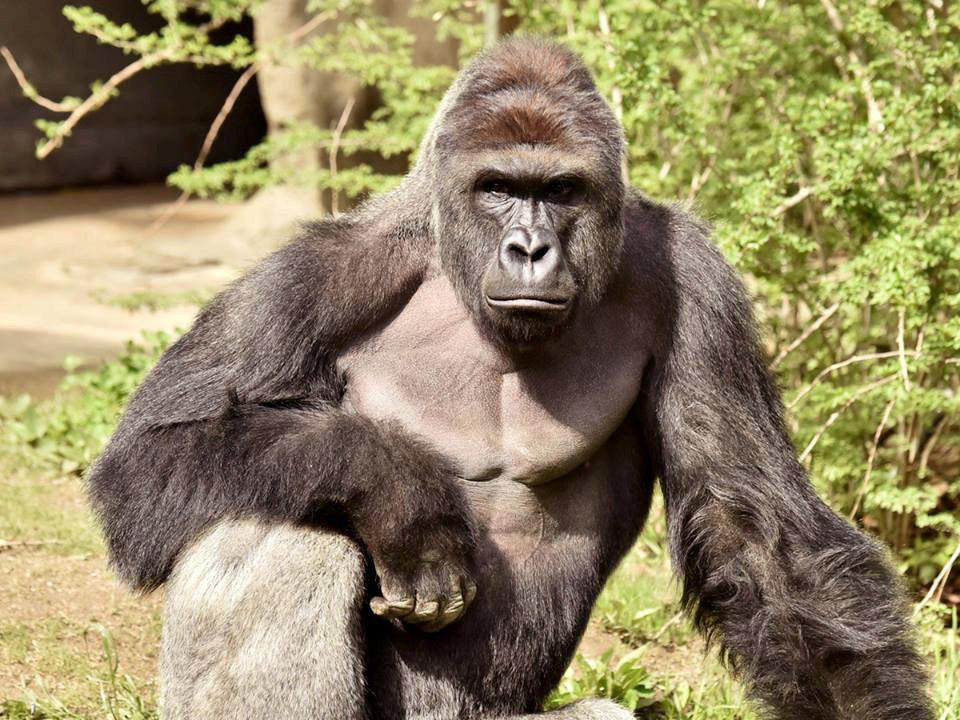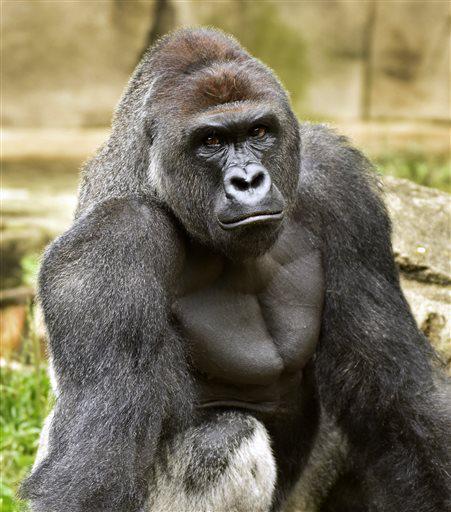The first image is the image on the left, the second image is the image on the right. For the images shown, is this caption "The right photo shows an adult gorilla interacting with a human being" true? Answer yes or no. No. The first image is the image on the left, the second image is the image on the right. For the images shown, is this caption "An image features one person gazing into the face of a large ape." true? Answer yes or no. No. 